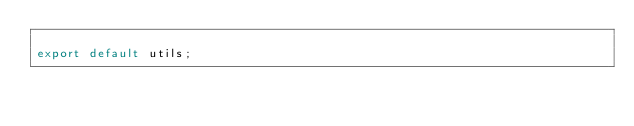<code> <loc_0><loc_0><loc_500><loc_500><_JavaScript_>
export default utils;</code> 